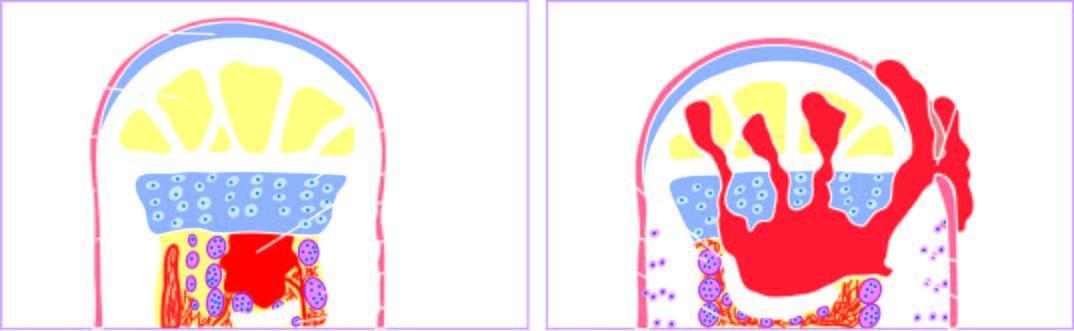does process begin as a focus of microabscess in a vascular loop in the marrow which expands to stimulate?
Answer the question using a single word or phrase. Yes 